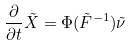<formula> <loc_0><loc_0><loc_500><loc_500>\frac { \partial } { \partial t } \tilde { X } = \Phi ( \tilde { F } ^ { - 1 } ) \tilde { \nu }</formula> 